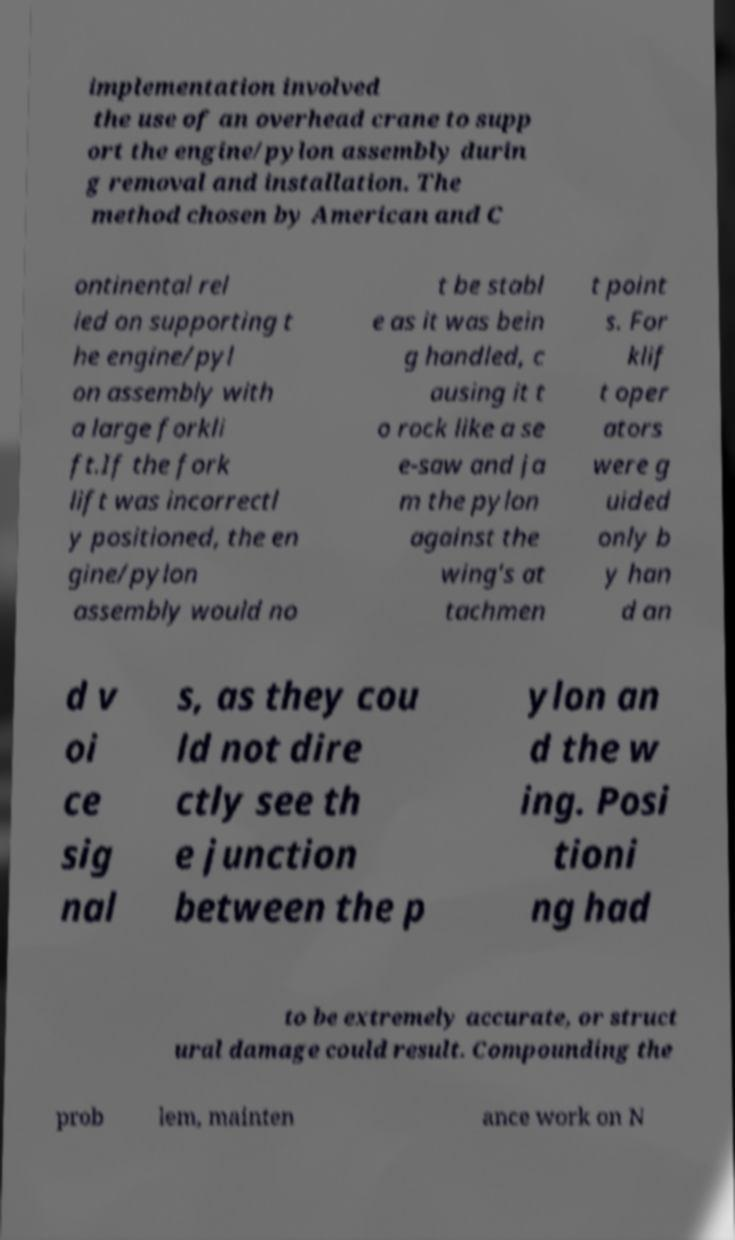What messages or text are displayed in this image? I need them in a readable, typed format. implementation involved the use of an overhead crane to supp ort the engine/pylon assembly durin g removal and installation. The method chosen by American and C ontinental rel ied on supporting t he engine/pyl on assembly with a large forkli ft.If the fork lift was incorrectl y positioned, the en gine/pylon assembly would no t be stabl e as it was bein g handled, c ausing it t o rock like a se e-saw and ja m the pylon against the wing's at tachmen t point s. For klif t oper ators were g uided only b y han d an d v oi ce sig nal s, as they cou ld not dire ctly see th e junction between the p ylon an d the w ing. Posi tioni ng had to be extremely accurate, or struct ural damage could result. Compounding the prob lem, mainten ance work on N 